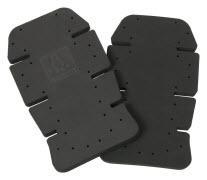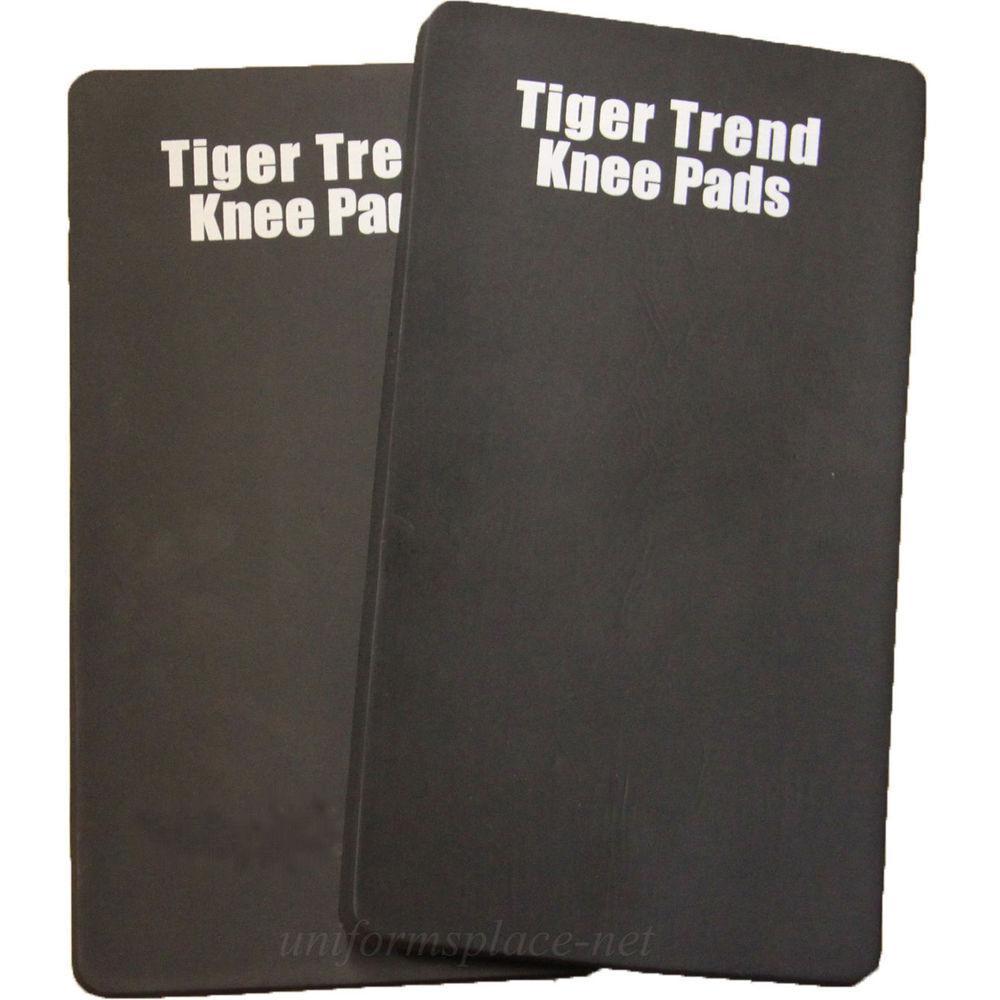The first image is the image on the left, the second image is the image on the right. Assess this claim about the two images: "At least one of the knee pads is textured.". Correct or not? Answer yes or no. No. The first image is the image on the left, the second image is the image on the right. Assess this claim about the two images: "An image shows a notched kneepad, with slits at the sides.". Correct or not? Answer yes or no. Yes. 